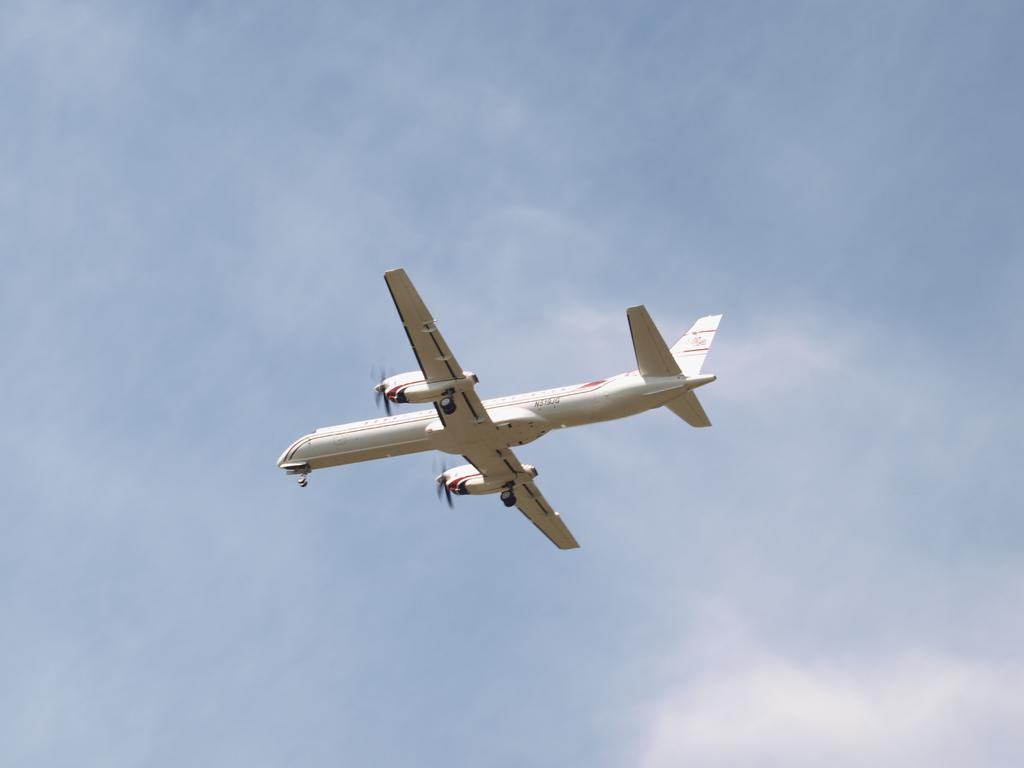What is the main subject of the image? The main subject of the image is an airplane. Where is the airplane located in the image? The airplane is in the air. What can be seen in the background of the image? The sky is visible in the image. What is the condition of the sky in the image? Clouds are present in the sky. What historical event is being commemorated by the airplane in the image? There is no indication of a historical event being commemorated in the image; it simply shows an airplane in the sky. What type of throat medicine is being advertised by the airplane in the image? There is no advertisement or reference to throat medicine in the image; it only features an airplane in the sky. 